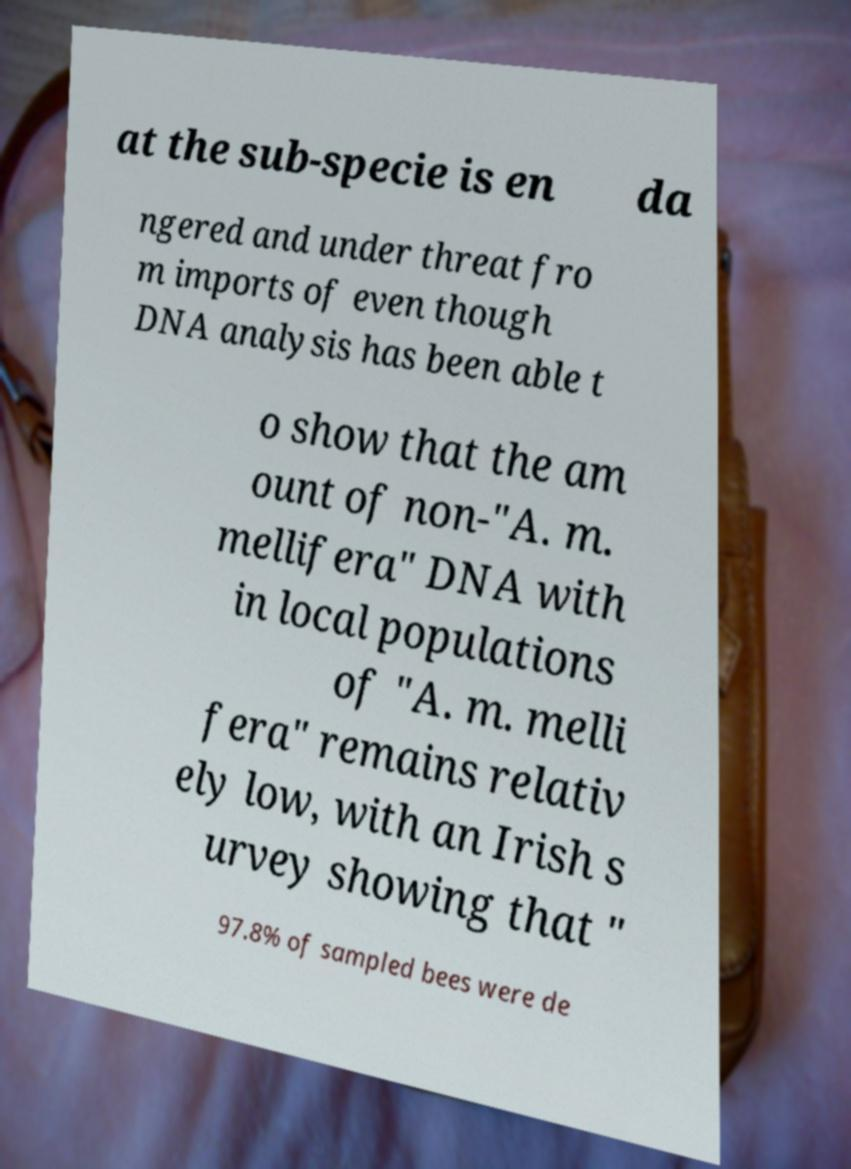I need the written content from this picture converted into text. Can you do that? at the sub-specie is en da ngered and under threat fro m imports of even though DNA analysis has been able t o show that the am ount of non-"A. m. mellifera" DNA with in local populations of "A. m. melli fera" remains relativ ely low, with an Irish s urvey showing that " 97.8% of sampled bees were de 